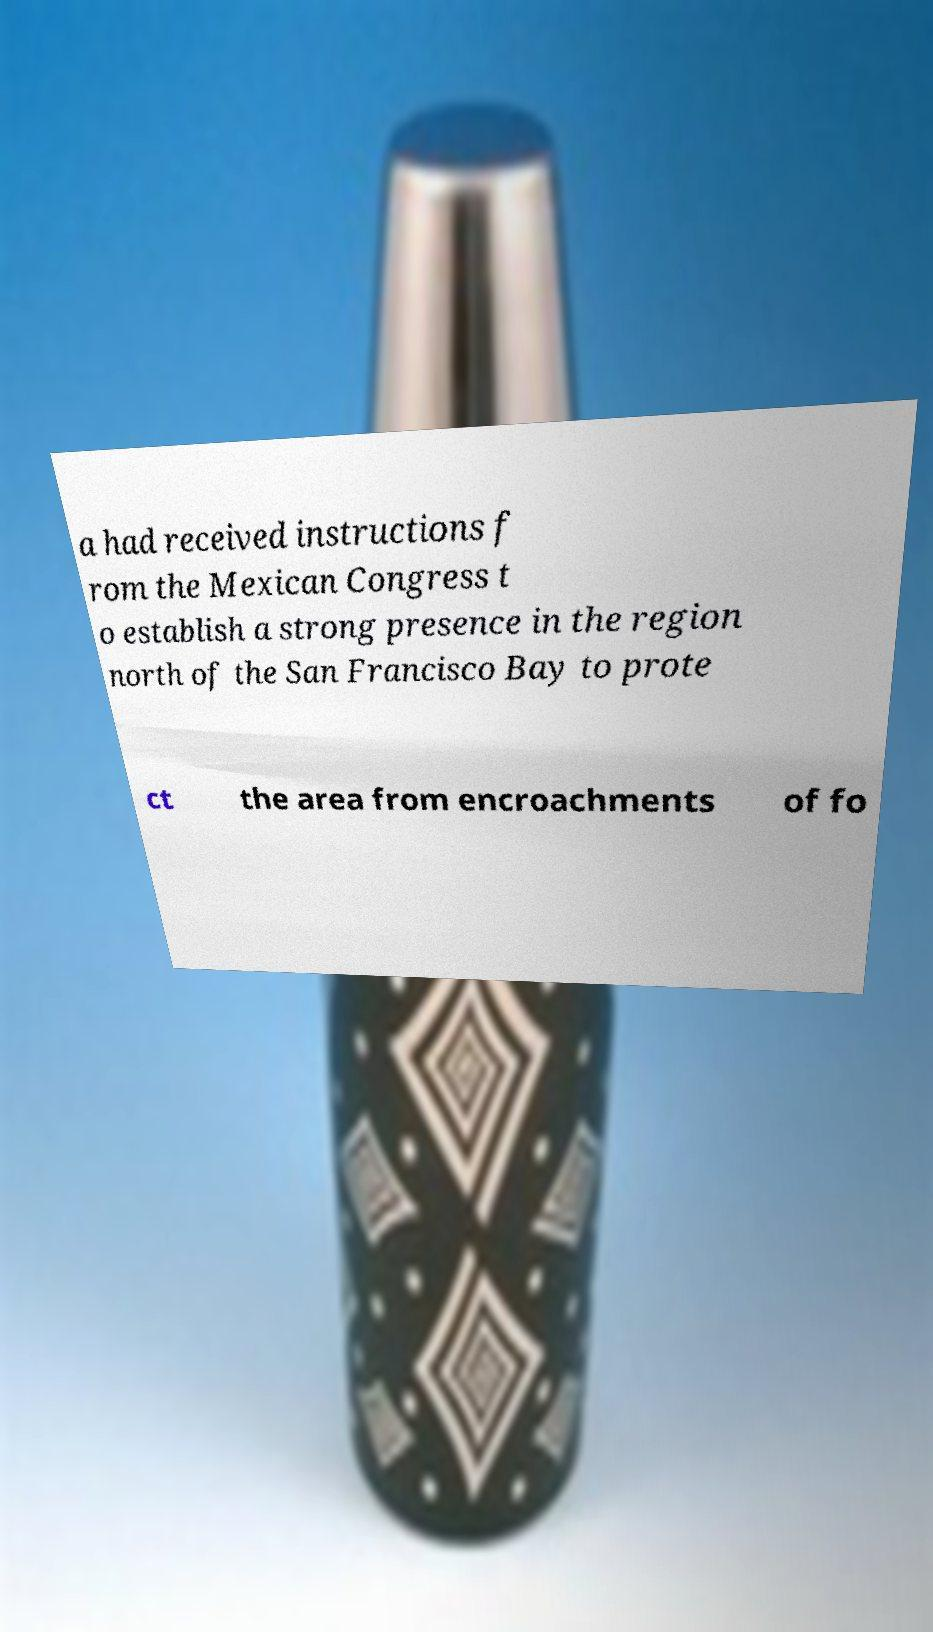Could you assist in decoding the text presented in this image and type it out clearly? a had received instructions f rom the Mexican Congress t o establish a strong presence in the region north of the San Francisco Bay to prote ct the area from encroachments of fo 